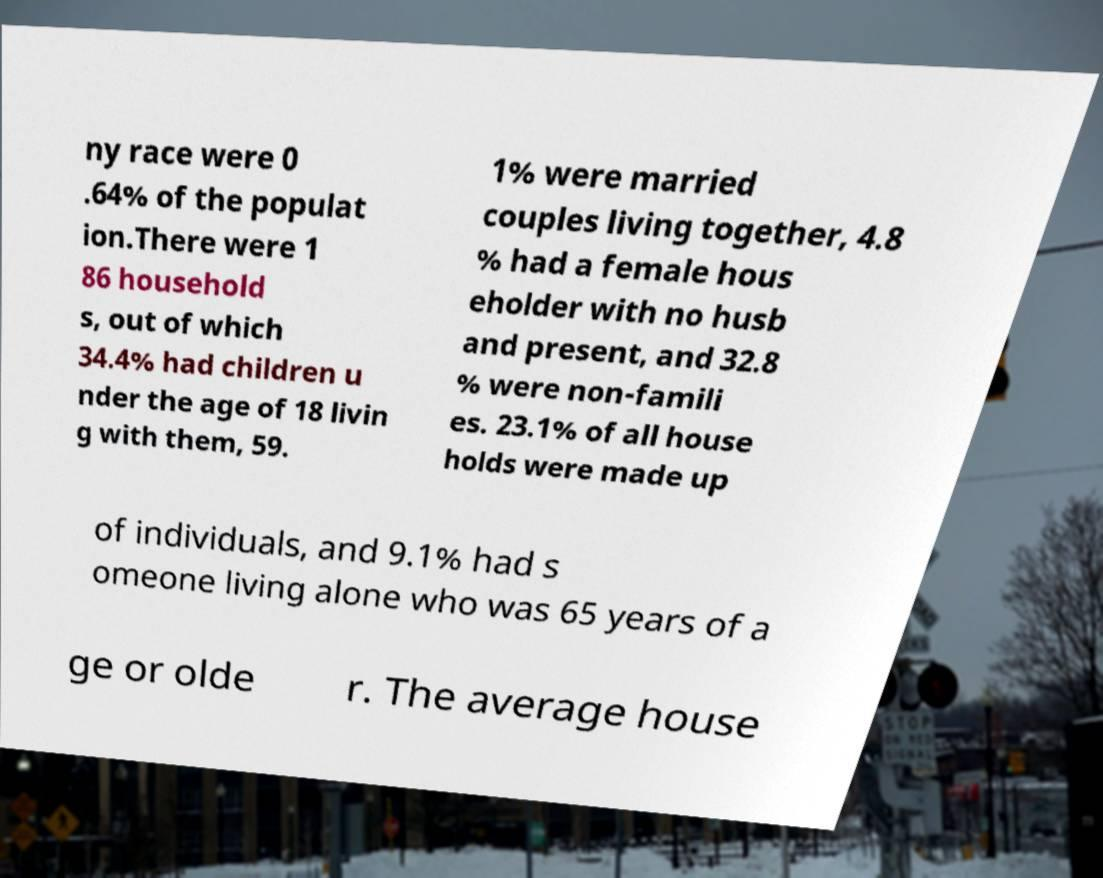For documentation purposes, I need the text within this image transcribed. Could you provide that? ny race were 0 .64% of the populat ion.There were 1 86 household s, out of which 34.4% had children u nder the age of 18 livin g with them, 59. 1% were married couples living together, 4.8 % had a female hous eholder with no husb and present, and 32.8 % were non-famili es. 23.1% of all house holds were made up of individuals, and 9.1% had s omeone living alone who was 65 years of a ge or olde r. The average house 